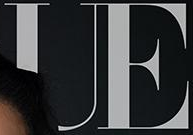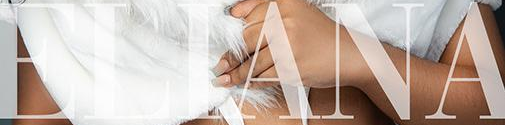Read the text from these images in sequence, separated by a semicolon. UE; ELIANA 